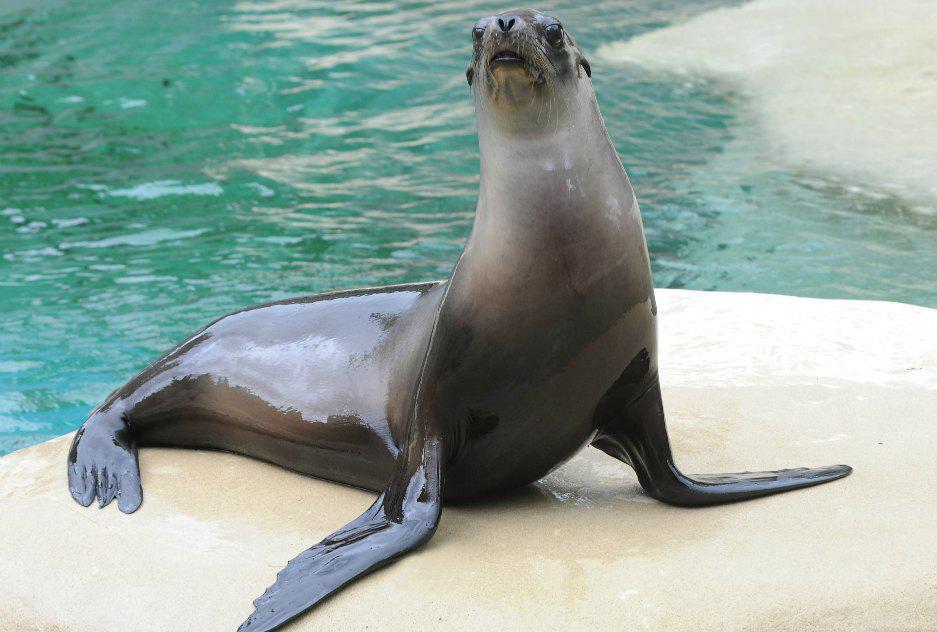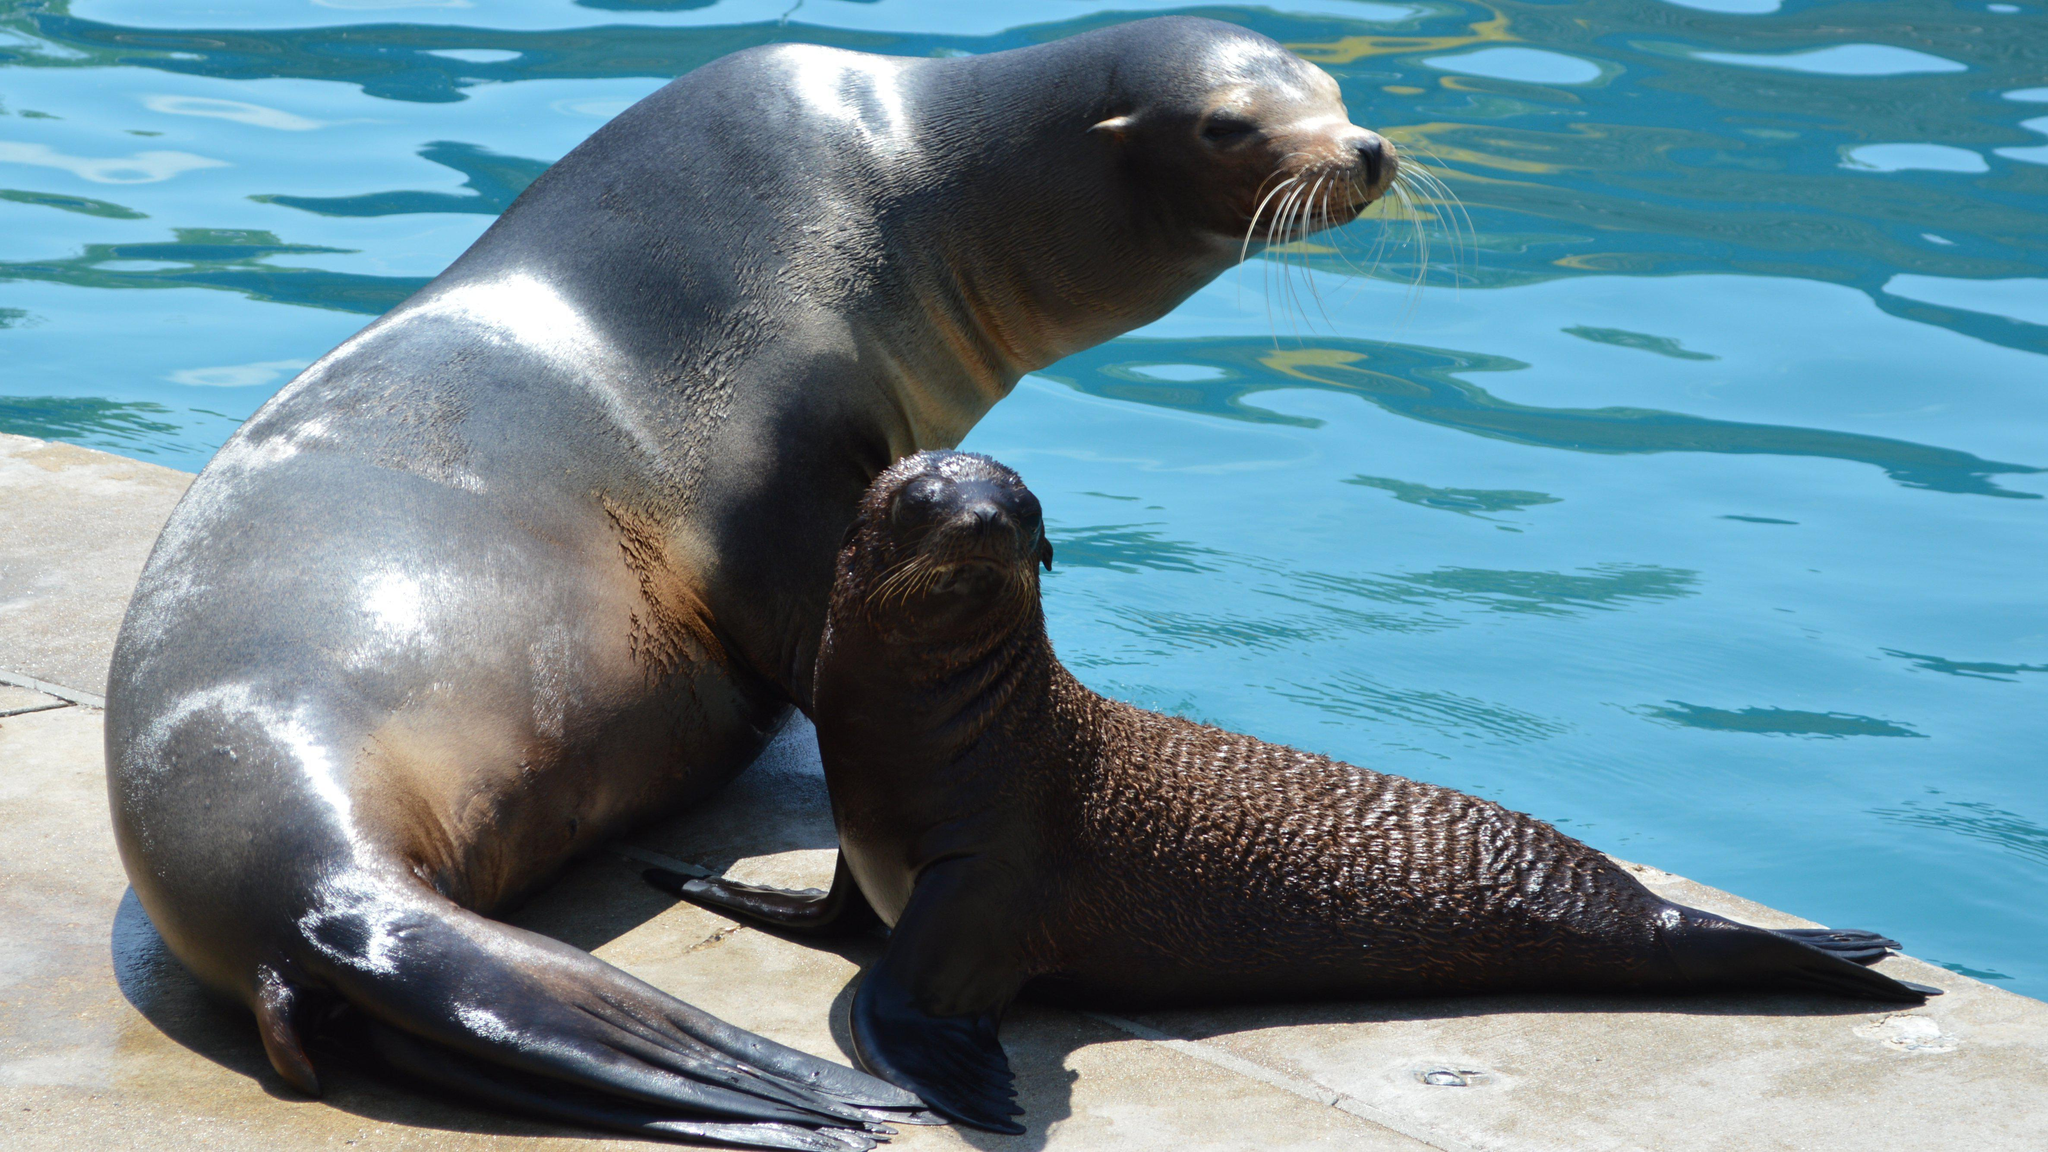The first image is the image on the left, the second image is the image on the right. For the images shown, is this caption "The right image contains exactly two seals." true? Answer yes or no. Yes. 